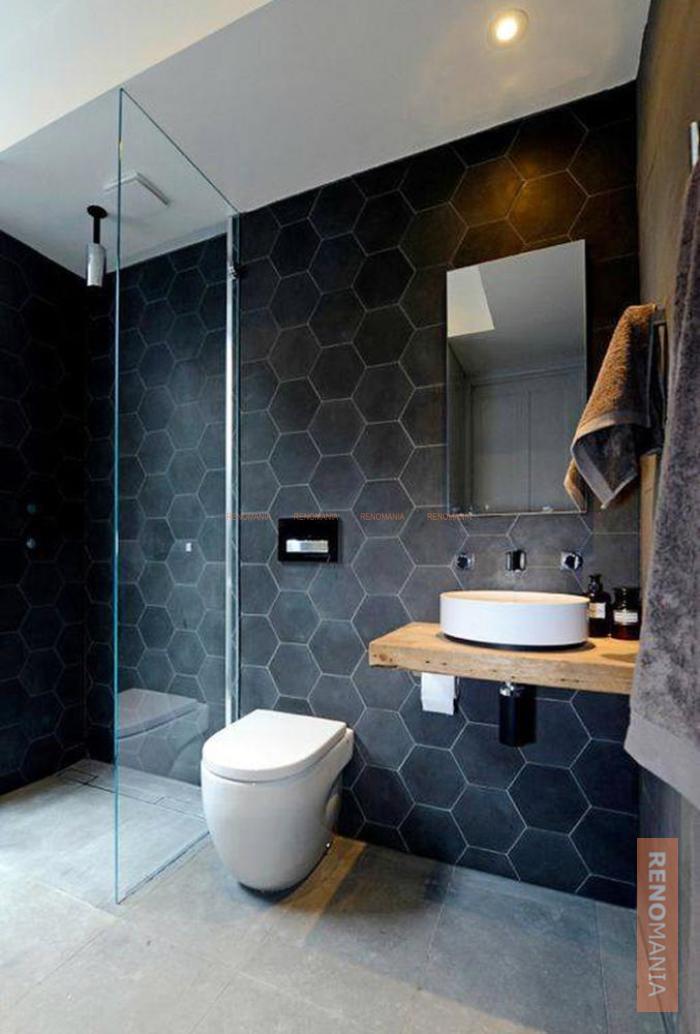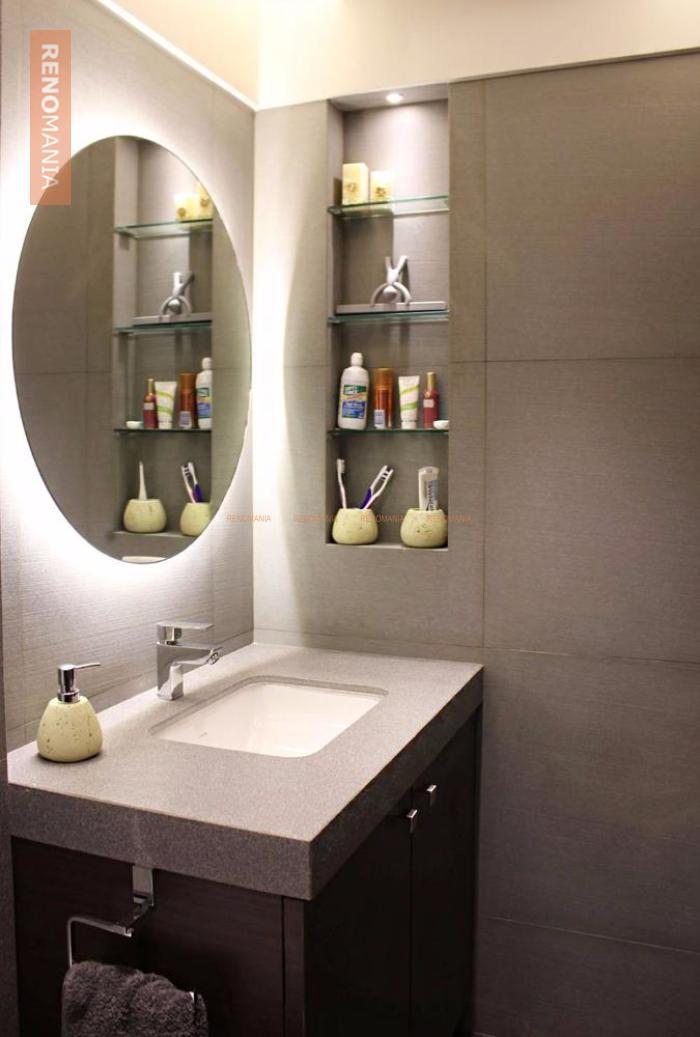The first image is the image on the left, the second image is the image on the right. For the images displayed, is the sentence "An image shows a stainless steel, double basin sink with plants nearby." factually correct? Answer yes or no. No. 